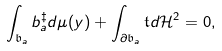<formula> <loc_0><loc_0><loc_500><loc_500>\int _ { \mathfrak { b } _ { a } } b _ { a } ^ { \ddagger } d \mu ( y ) + \int _ { \partial \mathfrak { b } _ { a } } \mathfrak { t } d \mathcal { H } ^ { 2 } = 0 ,</formula> 